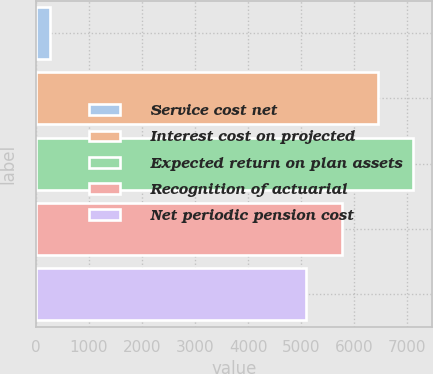<chart> <loc_0><loc_0><loc_500><loc_500><bar_chart><fcel>Service cost net<fcel>Interest cost on projected<fcel>Expected return on plan assets<fcel>Recognition of actuarial<fcel>Net periodic pension cost<nl><fcel>264<fcel>6439<fcel>7103.2<fcel>5758.2<fcel>5094<nl></chart> 